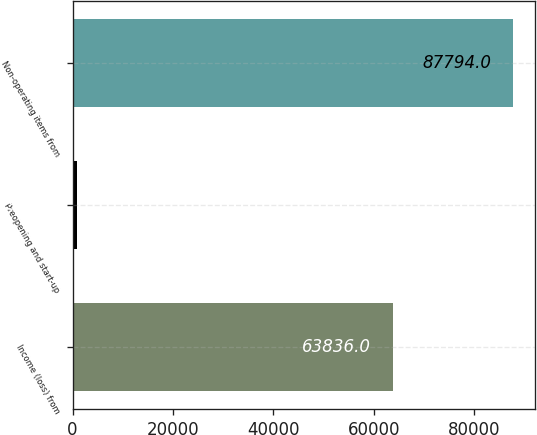<chart> <loc_0><loc_0><loc_500><loc_500><bar_chart><fcel>Income (loss) from<fcel>Preopening and start-up<fcel>Non-operating items from<nl><fcel>63836<fcel>917<fcel>87794<nl></chart> 